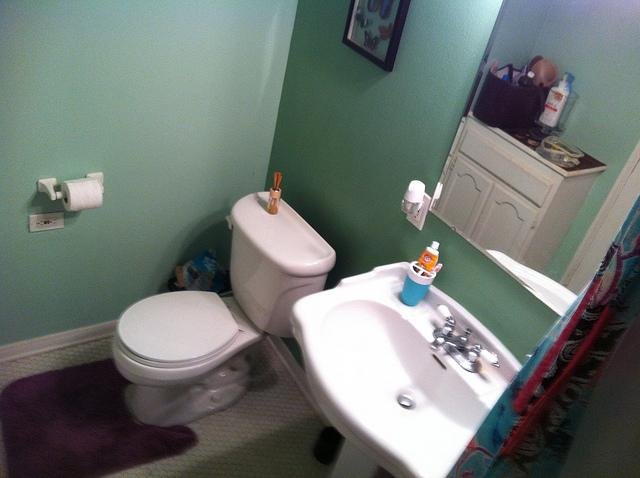What is likely in the large bottle in the reflection? lotion 